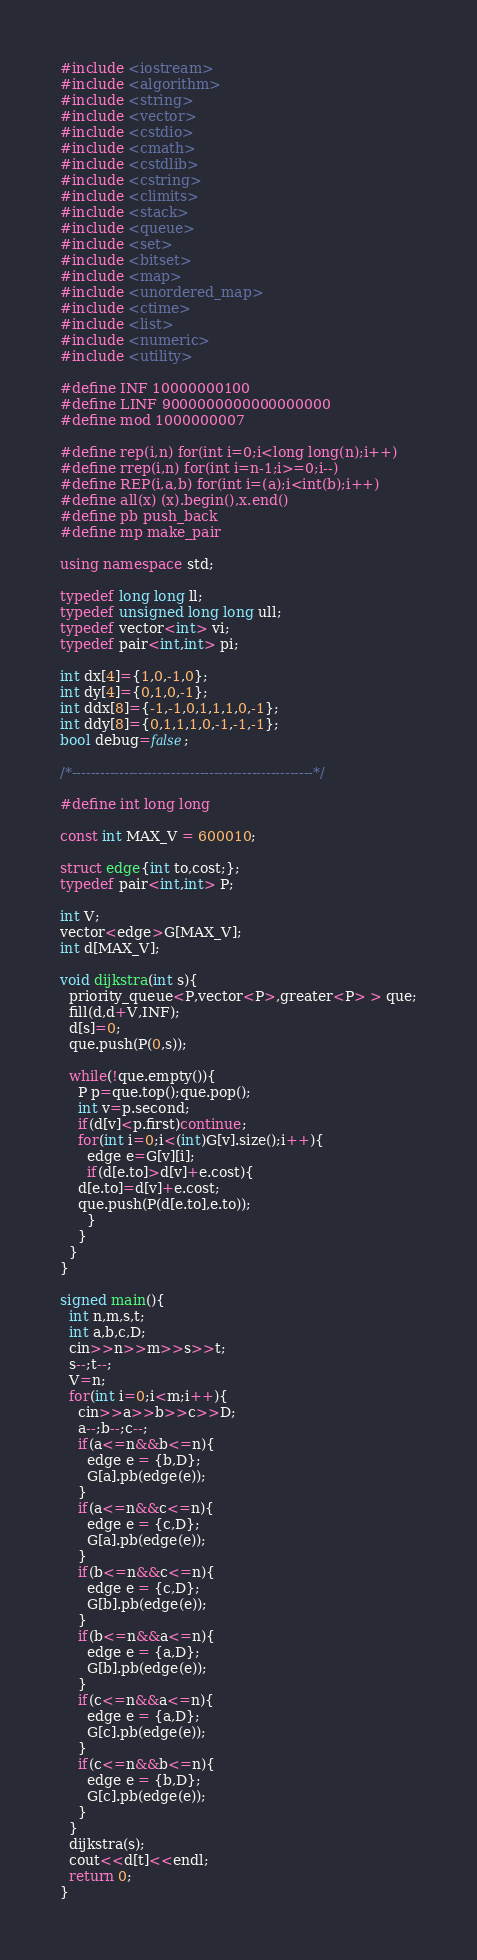Convert code to text. <code><loc_0><loc_0><loc_500><loc_500><_C++_>#include <iostream>
#include <algorithm>
#include <string>
#include <vector>
#include <cstdio>
#include <cmath>
#include <cstdlib>
#include <cstring>
#include <climits>
#include <stack>
#include <queue>
#include <set>
#include <bitset>
#include <map>
#include <unordered_map>
#include <ctime>
#include <list>
#include <numeric>
#include <utility>

#define INF 10000000100
#define LINF 9000000000000000000
#define mod 1000000007

#define rep(i,n) for(int i=0;i<long long(n);i++)
#define rrep(i,n) for(int i=n-1;i>=0;i--)
#define REP(i,a,b) for(int i=(a);i<int(b);i++)
#define all(x) (x).begin(),x.end()
#define pb push_back
#define mp make_pair

using namespace std;

typedef long long ll;
typedef unsigned long long ull;
typedef vector<int> vi;
typedef pair<int,int> pi;

int dx[4]={1,0,-1,0};
int dy[4]={0,1,0,-1};
int ddx[8]={-1,-1,0,1,1,1,0,-1};
int ddy[8]={0,1,1,1,0,-1,-1,-1};
bool debug=false;

/*---------------------------------------------------*/

#define int long long

const int MAX_V = 600010;

struct edge{int to,cost;};
typedef pair<int,int> P;

int V;
vector<edge>G[MAX_V];
int d[MAX_V];

void dijkstra(int s){
  priority_queue<P,vector<P>,greater<P> > que;
  fill(d,d+V,INF);
  d[s]=0;
  que.push(P(0,s));

  while(!que.empty()){
    P p=que.top();que.pop();
    int v=p.second;
    if(d[v]<p.first)continue;
    for(int i=0;i<(int)G[v].size();i++){
      edge e=G[v][i];
      if(d[e.to]>d[v]+e.cost){
	d[e.to]=d[v]+e.cost;
	que.push(P(d[e.to],e.to));
      }
    }
  }
}

signed main(){
  int n,m,s,t;
  int a,b,c,D;
  cin>>n>>m>>s>>t;
  s--;t--;
  V=n;
  for(int i=0;i<m;i++){
    cin>>a>>b>>c>>D;
    a--;b--;c--;
    if(a<=n&&b<=n){
      edge e = {b,D};
      G[a].pb(edge(e));
    }
    if(a<=n&&c<=n){
      edge e = {c,D};
      G[a].pb(edge(e));
    }
    if(b<=n&&c<=n){
      edge e = {c,D};
      G[b].pb(edge(e));
    }
    if(b<=n&&a<=n){
      edge e = {a,D};
      G[b].pb(edge(e));
    }
    if(c<=n&&a<=n){
      edge e = {a,D};
      G[c].pb(edge(e));
    }
    if(c<=n&&b<=n){
      edge e = {b,D};
      G[c].pb(edge(e));
    }
  }
  dijkstra(s);
  cout<<d[t]<<endl;
  return 0;
}

</code> 